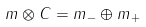Convert formula to latex. <formula><loc_0><loc_0><loc_500><loc_500>m \otimes C = m _ { - } \oplus m _ { + }</formula> 